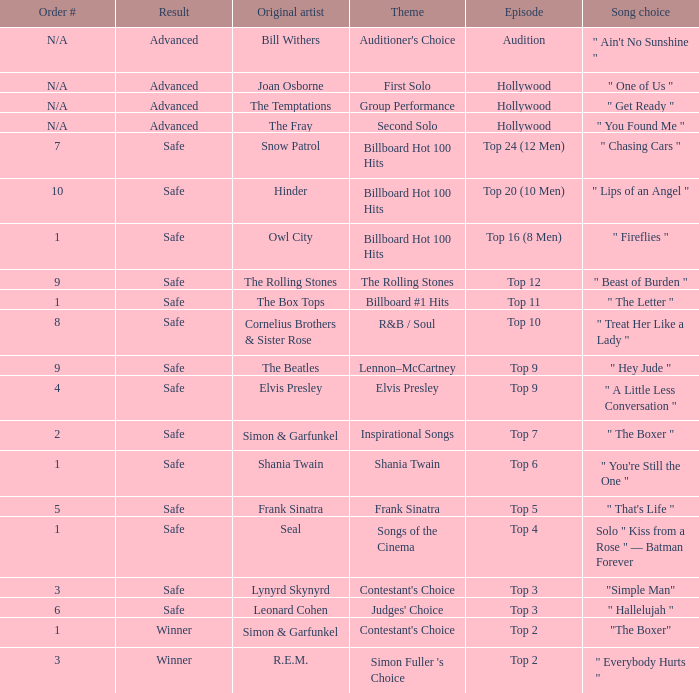In episode Top 16 (8 Men), what are the themes? Billboard Hot 100 Hits. Can you give me this table as a dict? {'header': ['Order #', 'Result', 'Original artist', 'Theme', 'Episode', 'Song choice'], 'rows': [['N/A', 'Advanced', 'Bill Withers', "Auditioner's Choice", 'Audition', '" Ain\'t No Sunshine "'], ['N/A', 'Advanced', 'Joan Osborne', 'First Solo', 'Hollywood', '" One of Us "'], ['N/A', 'Advanced', 'The Temptations', 'Group Performance', 'Hollywood', '" Get Ready "'], ['N/A', 'Advanced', 'The Fray', 'Second Solo', 'Hollywood', '" You Found Me "'], ['7', 'Safe', 'Snow Patrol', 'Billboard Hot 100 Hits', 'Top 24 (12 Men)', '" Chasing Cars "'], ['10', 'Safe', 'Hinder', 'Billboard Hot 100 Hits', 'Top 20 (10 Men)', '" Lips of an Angel "'], ['1', 'Safe', 'Owl City', 'Billboard Hot 100 Hits', 'Top 16 (8 Men)', '" Fireflies "'], ['9', 'Safe', 'The Rolling Stones', 'The Rolling Stones', 'Top 12', '" Beast of Burden "'], ['1', 'Safe', 'The Box Tops', 'Billboard #1 Hits', 'Top 11', '" The Letter "'], ['8', 'Safe', 'Cornelius Brothers & Sister Rose', 'R&B / Soul', 'Top 10', '" Treat Her Like a Lady "'], ['9', 'Safe', 'The Beatles', 'Lennon–McCartney', 'Top 9', '" Hey Jude "'], ['4', 'Safe', 'Elvis Presley', 'Elvis Presley', 'Top 9', '" A Little Less Conversation "'], ['2', 'Safe', 'Simon & Garfunkel', 'Inspirational Songs', 'Top 7', '" The Boxer "'], ['1', 'Safe', 'Shania Twain', 'Shania Twain', 'Top 6', '" You\'re Still the One "'], ['5', 'Safe', 'Frank Sinatra', 'Frank Sinatra', 'Top 5', '" That\'s Life "'], ['1', 'Safe', 'Seal', 'Songs of the Cinema', 'Top 4', 'Solo " Kiss from a Rose " — Batman Forever'], ['3', 'Safe', 'Lynyrd Skynyrd', "Contestant's Choice", 'Top 3', '"Simple Man"'], ['6', 'Safe', 'Leonard Cohen', "Judges' Choice", 'Top 3', '" Hallelujah "'], ['1', 'Winner', 'Simon & Garfunkel', "Contestant's Choice", 'Top 2', '"The Boxer"'], ['3', 'Winner', 'R.E.M.', "Simon Fuller 's Choice", 'Top 2', '" Everybody Hurts "']]} 